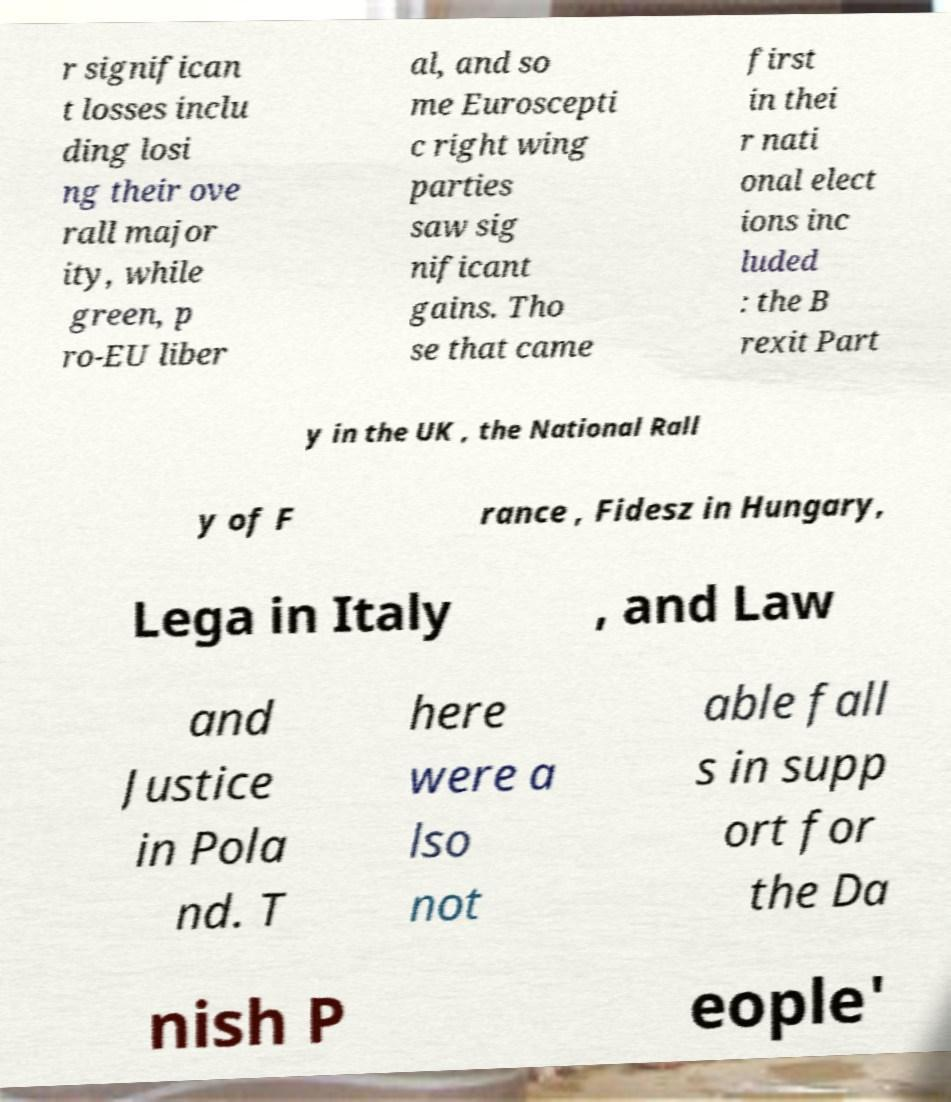Could you extract and type out the text from this image? r significan t losses inclu ding losi ng their ove rall major ity, while green, p ro-EU liber al, and so me Euroscepti c right wing parties saw sig nificant gains. Tho se that came first in thei r nati onal elect ions inc luded : the B rexit Part y in the UK , the National Rall y of F rance , Fidesz in Hungary, Lega in Italy , and Law and Justice in Pola nd. T here were a lso not able fall s in supp ort for the Da nish P eople' 